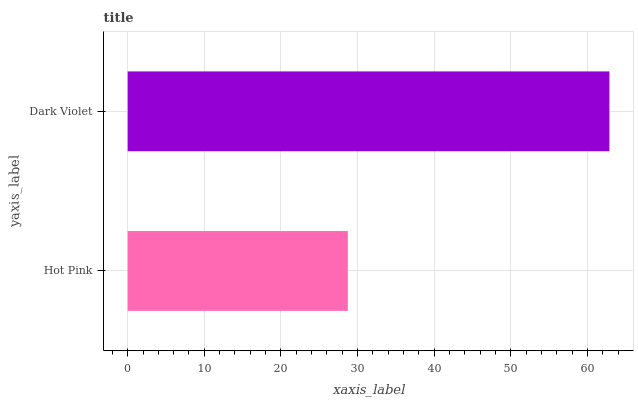Is Hot Pink the minimum?
Answer yes or no. Yes. Is Dark Violet the maximum?
Answer yes or no. Yes. Is Dark Violet the minimum?
Answer yes or no. No. Is Dark Violet greater than Hot Pink?
Answer yes or no. Yes. Is Hot Pink less than Dark Violet?
Answer yes or no. Yes. Is Hot Pink greater than Dark Violet?
Answer yes or no. No. Is Dark Violet less than Hot Pink?
Answer yes or no. No. Is Dark Violet the high median?
Answer yes or no. Yes. Is Hot Pink the low median?
Answer yes or no. Yes. Is Hot Pink the high median?
Answer yes or no. No. Is Dark Violet the low median?
Answer yes or no. No. 